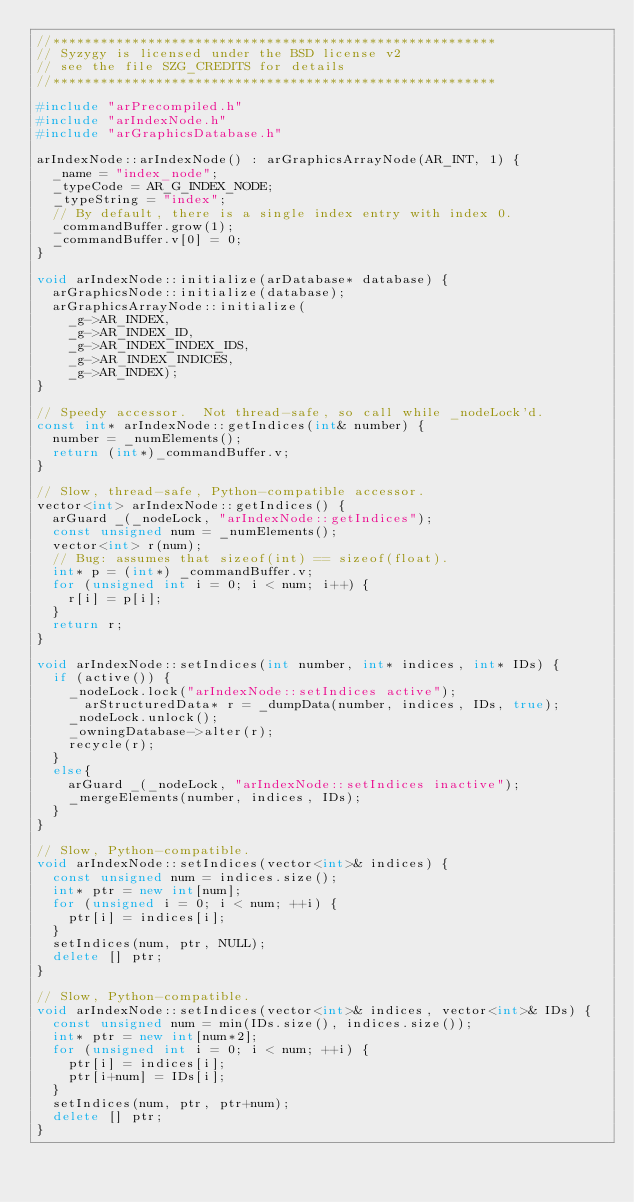<code> <loc_0><loc_0><loc_500><loc_500><_C++_>//********************************************************
// Syzygy is licensed under the BSD license v2
// see the file SZG_CREDITS for details
//********************************************************

#include "arPrecompiled.h"
#include "arIndexNode.h"
#include "arGraphicsDatabase.h"

arIndexNode::arIndexNode() : arGraphicsArrayNode(AR_INT, 1) {
  _name = "index_node";
  _typeCode = AR_G_INDEX_NODE;
  _typeString = "index";
  // By default, there is a single index entry with index 0.
  _commandBuffer.grow(1);
  _commandBuffer.v[0] = 0;
}

void arIndexNode::initialize(arDatabase* database) {
  arGraphicsNode::initialize(database);
  arGraphicsArrayNode::initialize(
    _g->AR_INDEX,
    _g->AR_INDEX_ID,
    _g->AR_INDEX_INDEX_IDS,
    _g->AR_INDEX_INDICES,
    _g->AR_INDEX);
}

// Speedy accessor.  Not thread-safe, so call while _nodeLock'd.
const int* arIndexNode::getIndices(int& number) {
  number = _numElements();
  return (int*)_commandBuffer.v;
}

// Slow, thread-safe, Python-compatible accessor.
vector<int> arIndexNode::getIndices() {
  arGuard _(_nodeLock, "arIndexNode::getIndices");
  const unsigned num = _numElements();
  vector<int> r(num);
  // Bug: assumes that sizeof(int) == sizeof(float).
  int* p = (int*) _commandBuffer.v;
  for (unsigned int i = 0; i < num; i++) {
    r[i] = p[i];
  }
  return r;
}

void arIndexNode::setIndices(int number, int* indices, int* IDs) {
  if (active()) {
    _nodeLock.lock("arIndexNode::setIndices active");
      arStructuredData* r = _dumpData(number, indices, IDs, true);
    _nodeLock.unlock();
    _owningDatabase->alter(r);
    recycle(r);
  }
  else{
    arGuard _(_nodeLock, "arIndexNode::setIndices inactive");
    _mergeElements(number, indices, IDs);
  }
}

// Slow, Python-compatible.
void arIndexNode::setIndices(vector<int>& indices) {
  const unsigned num = indices.size();
  int* ptr = new int[num];
  for (unsigned i = 0; i < num; ++i) {
    ptr[i] = indices[i];
  }
  setIndices(num, ptr, NULL);
  delete [] ptr;
}

// Slow, Python-compatible.
void arIndexNode::setIndices(vector<int>& indices, vector<int>& IDs) {
  const unsigned num = min(IDs.size(), indices.size());
  int* ptr = new int[num*2];
  for (unsigned int i = 0; i < num; ++i) {
    ptr[i] = indices[i];
    ptr[i+num] = IDs[i];
  }
  setIndices(num, ptr, ptr+num);
  delete [] ptr;
}
</code> 